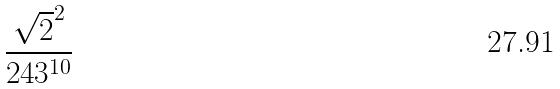<formula> <loc_0><loc_0><loc_500><loc_500>\frac { \sqrt { 2 } ^ { 2 } } { 2 4 3 ^ { 1 0 } }</formula> 